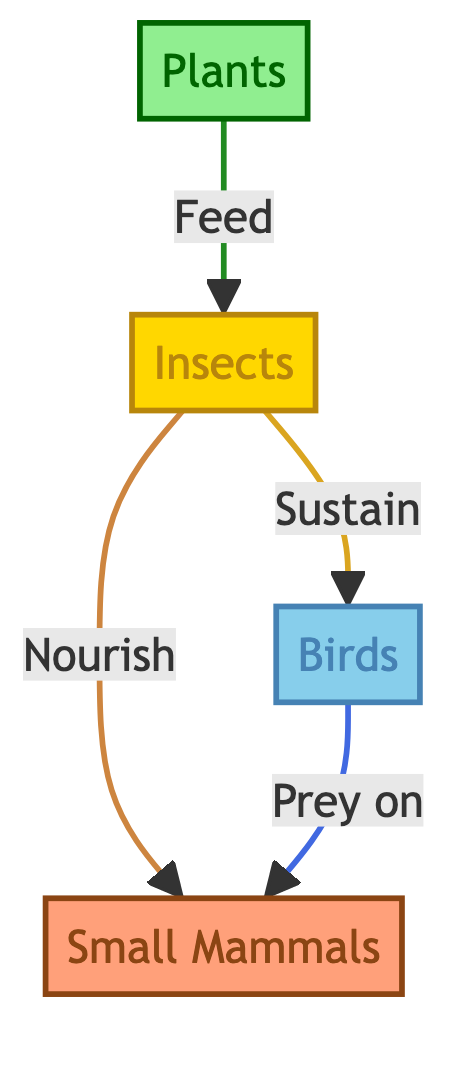What is the starting point of the food chain? The food chain begins with 'Plants' as the source of energy for other organisms.
Answer: Plants How many nodes are in the diagram? The diagram contains four nodes: Plants, Insects, Birds, and Small Mammals.
Answer: 4 Which organisms feed on Insects? Both 'Birds' and 'Small Mammals' derive nourishment from Insects, reflecting their roles in the food chain.
Answer: Birds, Small Mammals What is the relationship between Birds and Small Mammals? According to the diagram, Birds prey on Small Mammals, indicating a predator-prey relationship.
Answer: Prey on Which organism sustains Birds? Insects serve the role of sustaining Birds by providing the necessary nourishment as indicated in the diagram.
Answer: Insects What type of flow occurs from Plants to Insects? The flow from Plants to Insects is labeled as 'Feed,' indicating that Insects rely on Plants for their energy.
Answer: Feed How are Insects connected to Plants and Small Mammals? Insects are connected to Plants in a feeding direction and to Small Mammals in a nourishing direction, highlighting their central role in the food chain.
Answer: Feed, Nourish What is the classification color for Birds? The classification color for Birds in the diagram is a shade of blue, specifically '#87CEEB'.
Answer: Blue How do Birds and Small Mammals interact in the food chain? Birds interact with Small Mammals as predators, preying on them as indicated in the directional arrow between the two nodes.
Answer: Prey on 